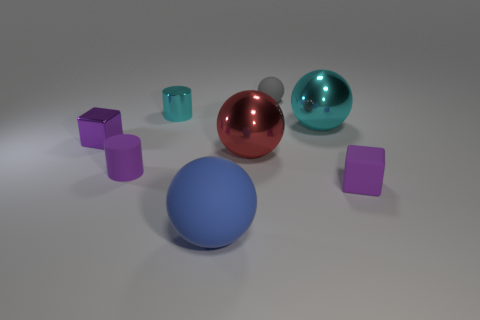What is the shape of the small cyan thing?
Keep it short and to the point. Cylinder. How many small things are the same material as the cyan cylinder?
Ensure brevity in your answer.  1. Is the color of the tiny shiny cylinder the same as the tiny block on the right side of the purple cylinder?
Your answer should be compact. No. Are there any small metal blocks that have the same color as the small matte cylinder?
Your response must be concise. Yes. There is a matte ball that is behind the big blue matte thing that is in front of the small purple rubber object right of the rubber cylinder; what is its color?
Your answer should be compact. Gray. Does the cyan cylinder have the same material as the big cyan ball that is behind the red metallic sphere?
Make the answer very short. Yes. What material is the cyan sphere?
Give a very brief answer. Metal. There is a large ball that is the same color as the metal cylinder; what material is it?
Offer a very short reply. Metal. How many other objects are the same material as the blue object?
Offer a very short reply. 3. What is the shape of the purple object that is right of the tiny purple shiny thing and left of the purple rubber cube?
Provide a succinct answer. Cylinder. 